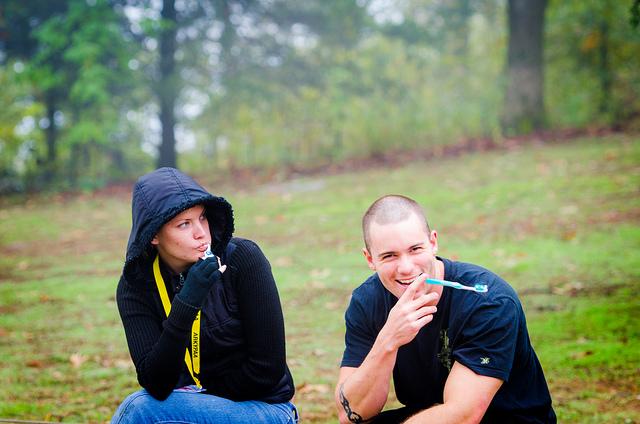How long is the man's hair?
Give a very brief answer. Short. What are the people doing?
Keep it brief. Brushing teeth. Is this a boy or girl on the left?
Write a very short answer. Girl. What do the people have in their mouths?
Answer briefly. Toothbrushes. Is the man dressed up in business attire?
Be succinct. No. What is the man wearing?
Keep it brief. Shirt. 